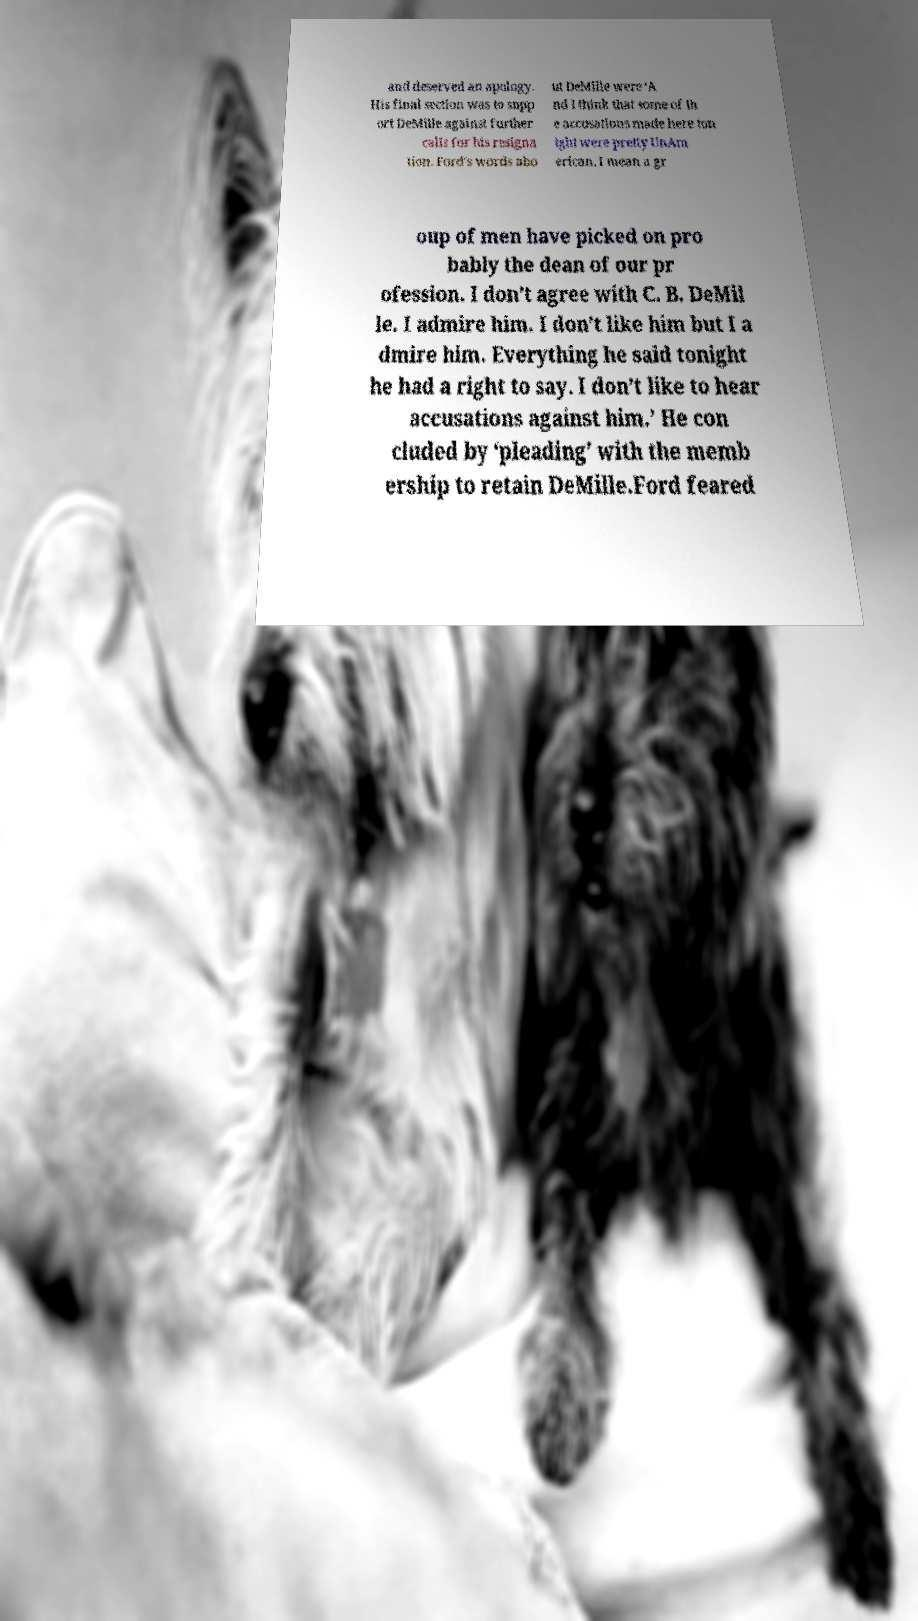Please read and relay the text visible in this image. What does it say? and deserved an apology. His final section was to supp ort DeMille against further calls for his resigna tion. Ford's words abo ut DeMille were ‘A nd I think that some of th e accusations made here ton ight were pretty UnAm erican. I mean a gr oup of men have picked on pro bably the dean of our pr ofession. I don’t agree with C. B. DeMil le. I admire him. I don’t like him but I a dmire him. Everything he said tonight he had a right to say. I don’t like to hear accusations against him.’ He con cluded by ‘pleading’ with the memb ership to retain DeMille.Ford feared 